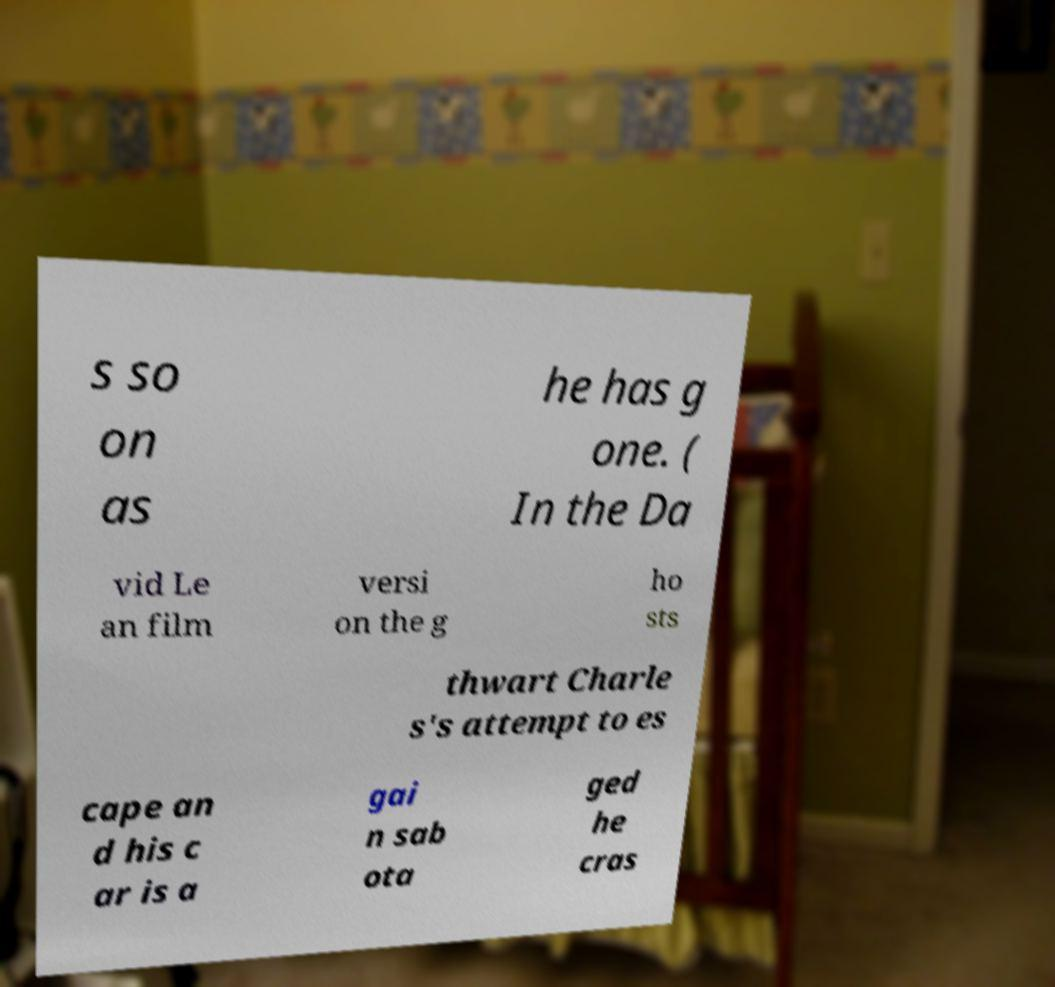There's text embedded in this image that I need extracted. Can you transcribe it verbatim? s so on as he has g one. ( In the Da vid Le an film versi on the g ho sts thwart Charle s's attempt to es cape an d his c ar is a gai n sab ota ged he cras 